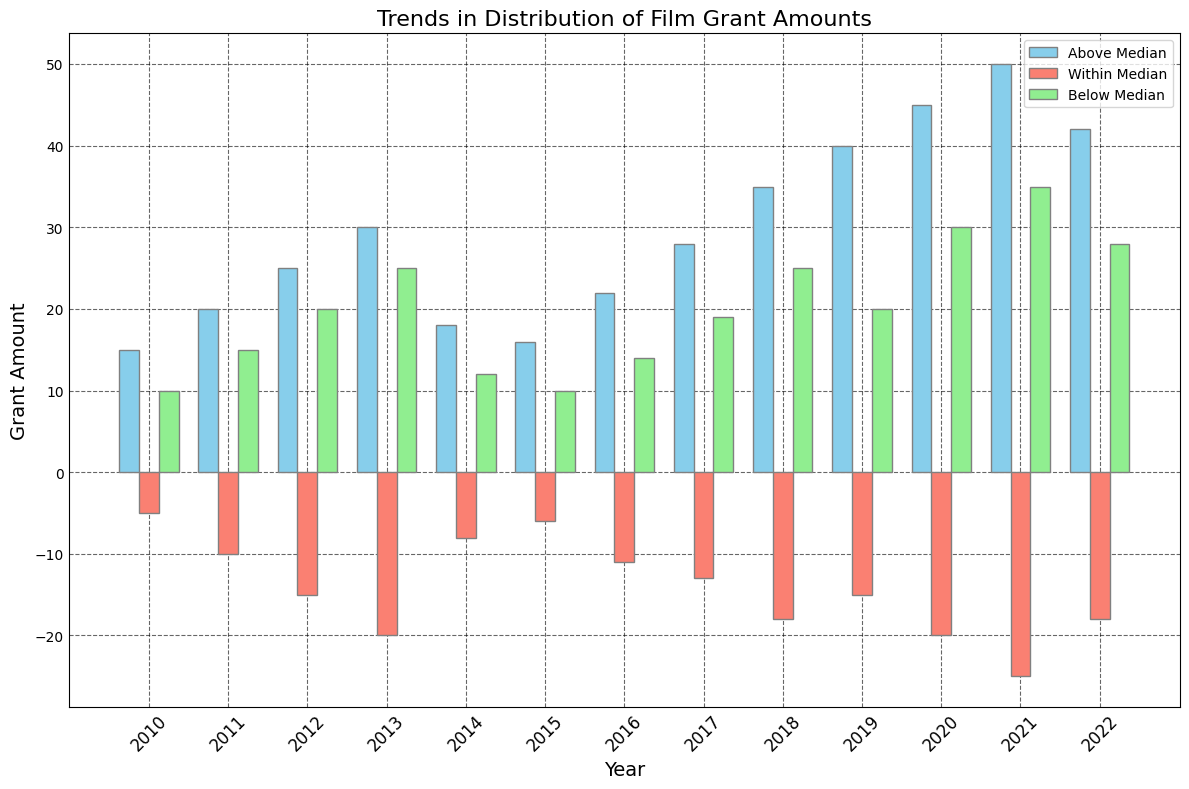What year had the highest grant amounts above the median? To find this, look at the bar labeled "Above Median" and identify the tallest bar. The tallest "Above Median" bar corresponds to the year 2021.
Answer: 2021 Which category consistently had negative values throughout the years? Review the three categories (Above Median, Within Median, Below Median). Only the "Within Median" category has bars below the x-axis, indicating negative values for all years.
Answer: Within Median How does the grant amount in the "Below Median" category for 2021 compare to 2020? Locate the bars for 2021 and 2020 in the "Below Median" category. The height of the 2021 bar is slightly higher than the 2020 bar. Thus, 2021 has a higher value.
Answer: 2021 is higher What is the trend in the "Above Median" grant amounts over the years? Track the heights of the "Above Median" bars across the years. The trend shows an overall increase from 2010 to 2022, peaking in 2021.
Answer: Increasing Which year had the smallest difference between "Above Median" and "Below Median" grant amounts? Calculate the difference for each year by subtracting "Below Median" from "Above Median". The smallest difference occurs in 2014 (18 - 12 = 6).
Answer: 2014 Is there any year where the sum of "Above Median" and "Below Median" is equal to 50? Calculate the sum for each year by adding the values of "Above Median" and "Below Median". 2018 is one such year (35 + 25 = 50).
Answer: 2018 In which year was the increase in "Above Median" grant amounts the largest compared to the previous year? Calculate the yearly increases by subtracting the previous year's "Above Median" value from the current year's value. The largest increase is from 2013 to 2014 (30 - 18 = 12).
Answer: 2013 to 2014 By how much did the "Within Median" grant amounts differ between 2021 and 2019? Subtract the "Within Median" value for 2019 from the one for 2021 (-25 - (-15) = -10). The difference is -10, indicating a decrease.
Answer: -10 What's the average amount of grants in the "Below Median" category from 2010 to 2015? Sum the values of the "Below Median" category from 2010 to 2015 and divide by 6. The total is (10 + 15 + 20 + 25 + 12 + 10) = 92, and the average is 92 / 6 = 15.33.
Answer: 15.33 Which year had the highest combined total of all three categories? Add "Above Median", "Within Median", and "Below Median" for each year and find the year with the highest sum. 2021 has the highest combined total (50 - 25 + 35 = 60).
Answer: 2021 